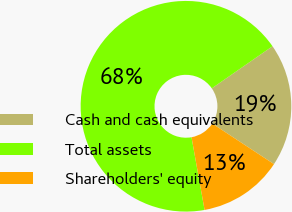Convert chart. <chart><loc_0><loc_0><loc_500><loc_500><pie_chart><fcel>Cash and cash equivalents<fcel>Total assets<fcel>Shareholders' equity<nl><fcel>18.91%<fcel>68.18%<fcel>12.92%<nl></chart> 